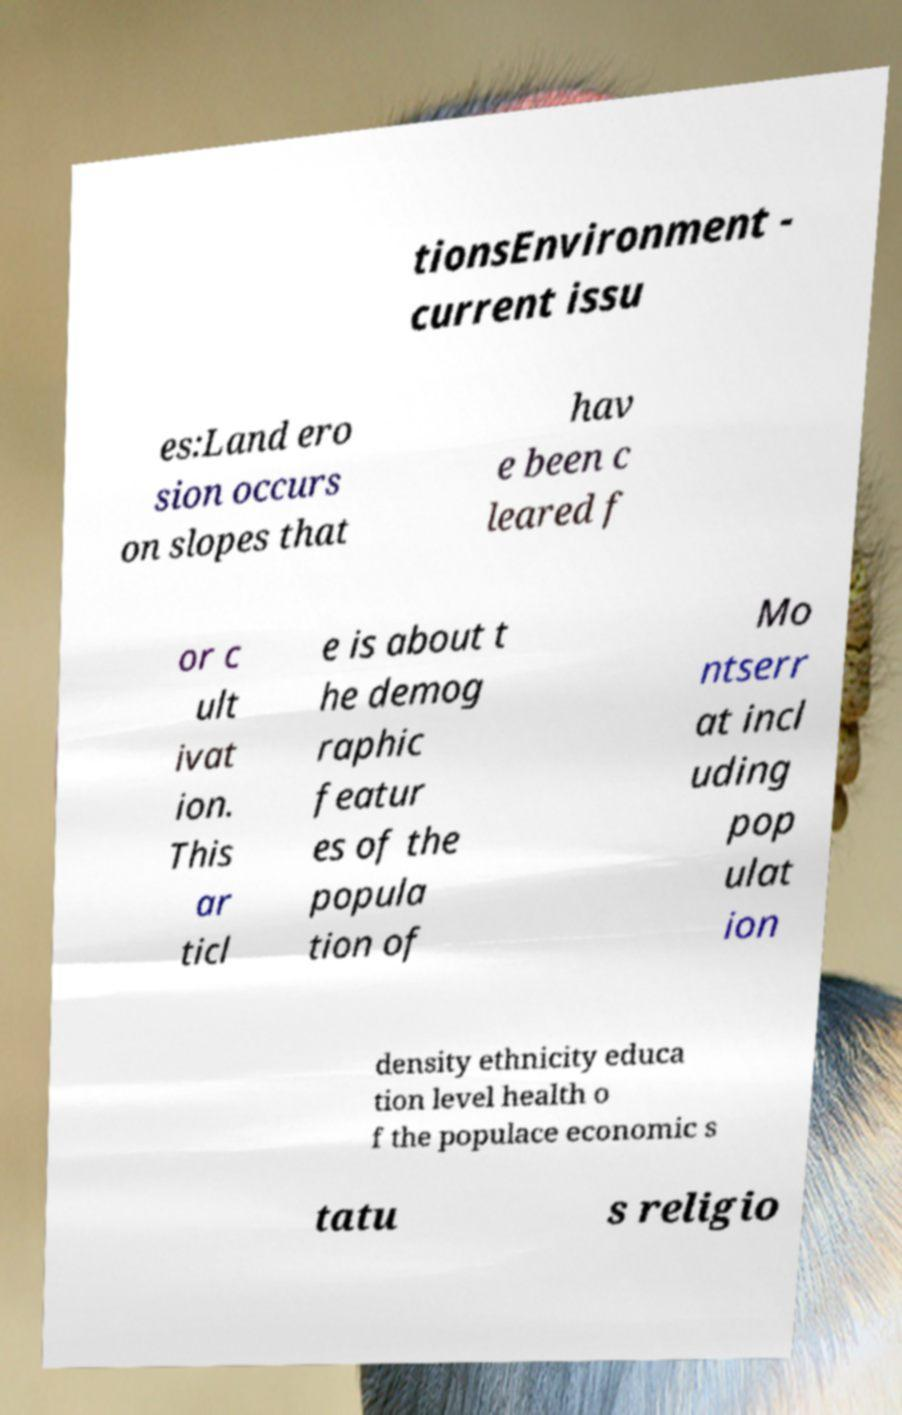I need the written content from this picture converted into text. Can you do that? tionsEnvironment - current issu es:Land ero sion occurs on slopes that hav e been c leared f or c ult ivat ion. This ar ticl e is about t he demog raphic featur es of the popula tion of Mo ntserr at incl uding pop ulat ion density ethnicity educa tion level health o f the populace economic s tatu s religio 